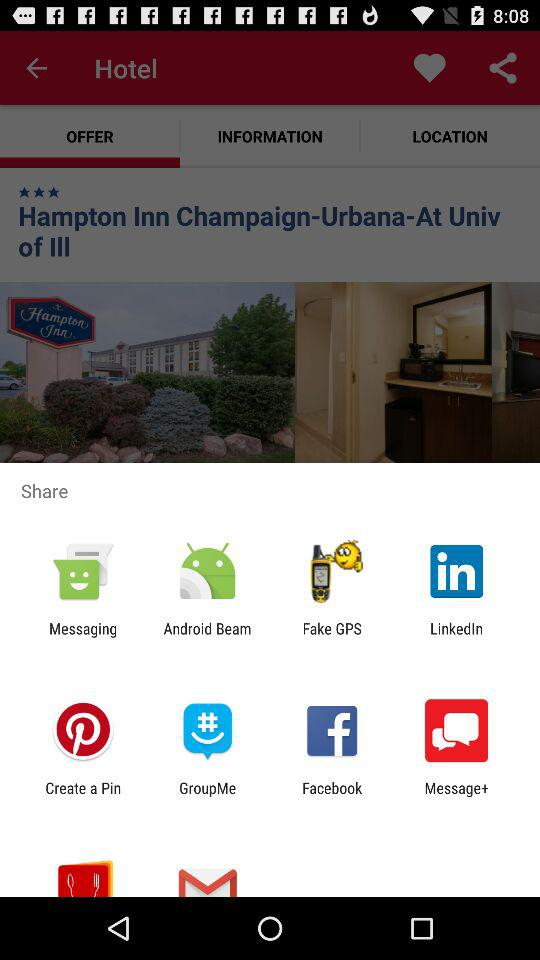Which tab is selected? The selected tab is "OFFER". 